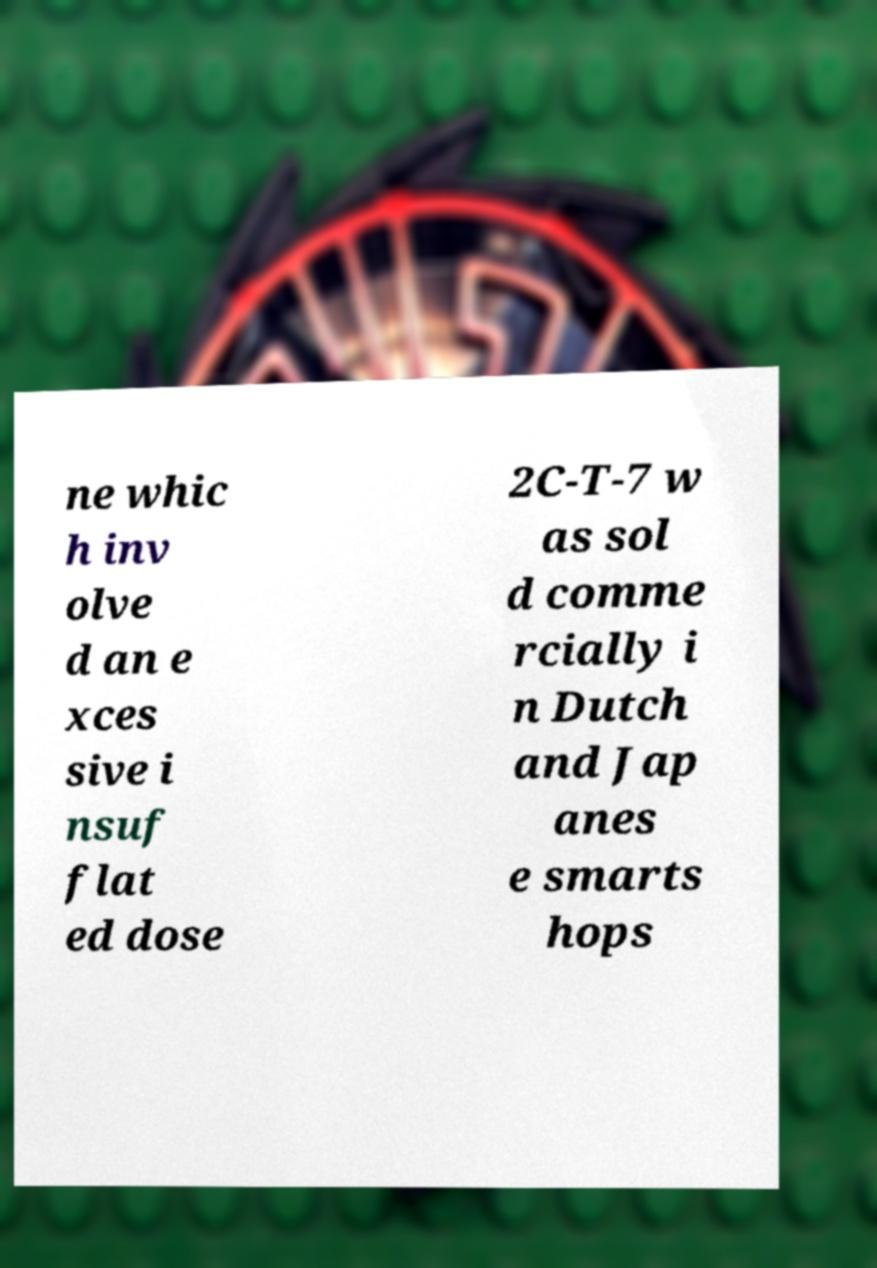Can you read and provide the text displayed in the image?This photo seems to have some interesting text. Can you extract and type it out for me? ne whic h inv olve d an e xces sive i nsuf flat ed dose 2C-T-7 w as sol d comme rcially i n Dutch and Jap anes e smarts hops 